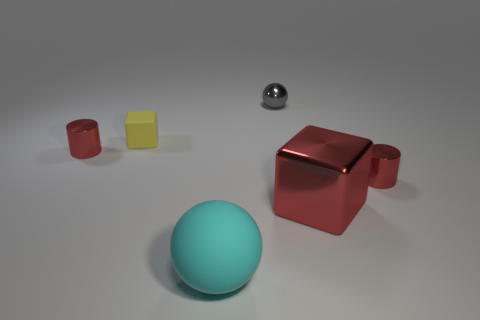Add 3 large blue rubber cylinders. How many objects exist? 9 Subtract all cubes. How many objects are left? 4 Add 6 small brown metallic spheres. How many small brown metallic spheres exist? 6 Subtract all yellow cubes. How many cubes are left? 1 Subtract 0 brown cylinders. How many objects are left? 6 Subtract 1 spheres. How many spheres are left? 1 Subtract all blue cubes. Subtract all cyan cylinders. How many cubes are left? 2 Subtract all small metal spheres. Subtract all red blocks. How many objects are left? 4 Add 3 small blocks. How many small blocks are left? 4 